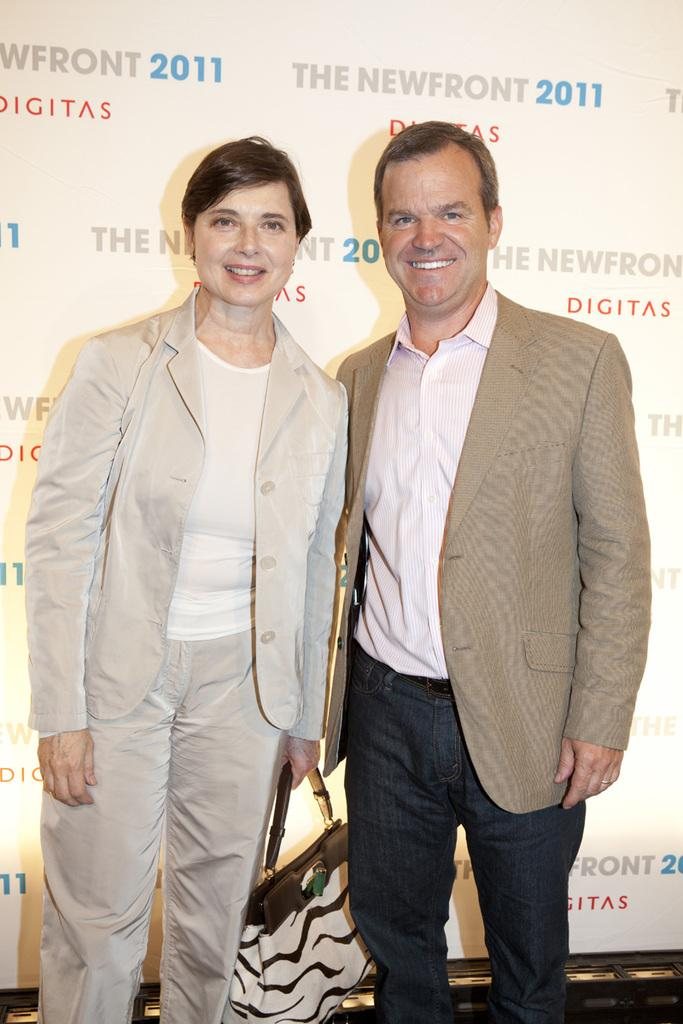How many people are in the image? There are two persons in the image. What are the people in the image doing? Both persons are standing. What expressions do the people have? The lady on the left is smiling, and the man on the right is smiling. What is the lady holding? The lady is holding a handbag. What type of secretary can be seen working in the image? There is no secretary present in the image; it features two people standing and smiling. 